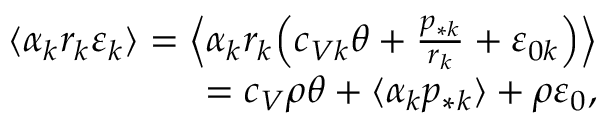Convert formula to latex. <formula><loc_0><loc_0><loc_500><loc_500>\begin{array} { r } { \langle \alpha _ { k } r _ { k } \varepsilon _ { k } \rangle = \left \langle \alpha _ { k } r _ { k } \left ( c _ { V k } \theta + \frac { p _ { * k } } { r _ { k } } + \varepsilon _ { 0 k } \right ) \right \rangle } \\ { = c _ { V } \rho \theta + \langle \alpha _ { k } p _ { * k } \rangle + \rho \varepsilon _ { 0 } , } \end{array}</formula> 